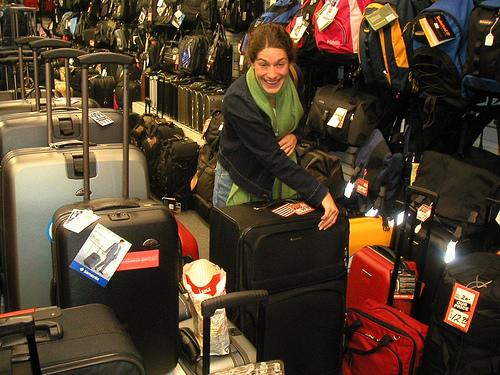What color is the scarf around the woman's neck?
Give a very brief answer. Green. Is this woman happy?
Be succinct. Yes. What is the woman shopping for?
Keep it brief. Luggage. 